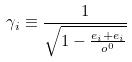Convert formula to latex. <formula><loc_0><loc_0><loc_500><loc_500>\gamma _ { i } \equiv \frac { 1 } { \sqrt { 1 - \frac { e _ { i } + e _ { i } } { o ^ { 0 } } } }</formula> 